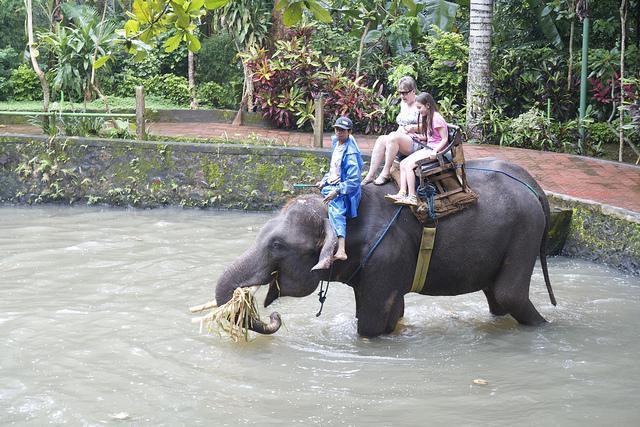How many people are riding this elephant?
Give a very brief answer. 3. How many people can you see?
Give a very brief answer. 3. How many giraffe in the picture?
Give a very brief answer. 0. 